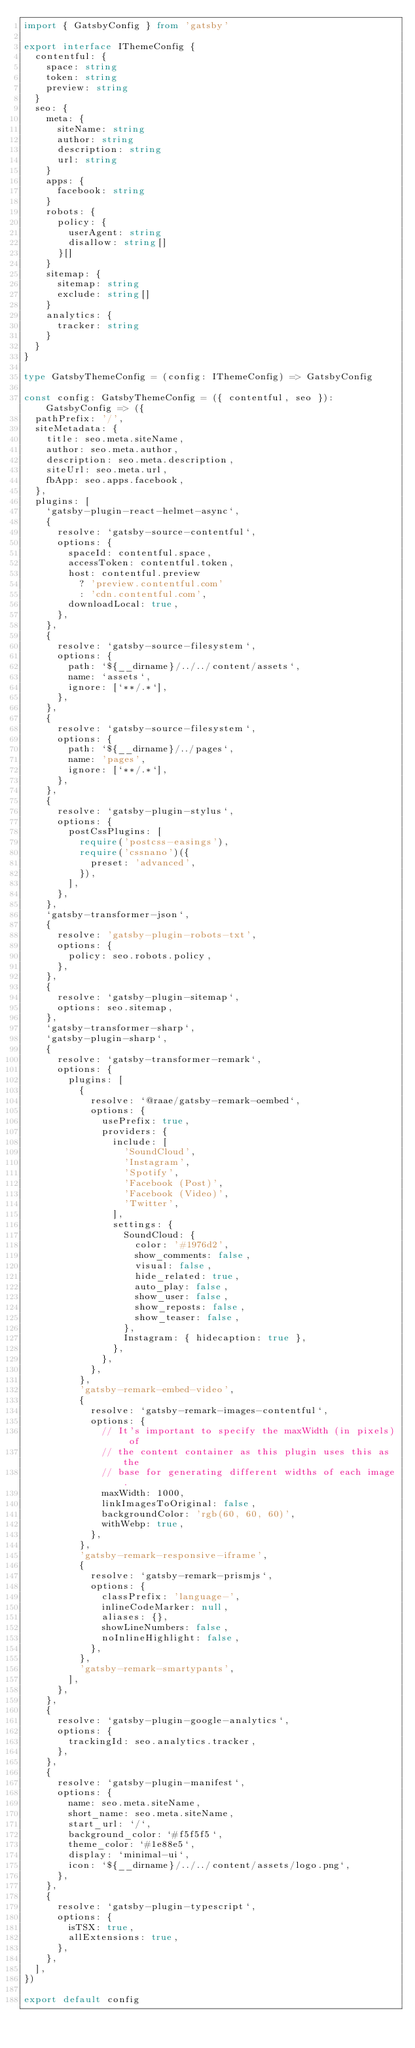Convert code to text. <code><loc_0><loc_0><loc_500><loc_500><_TypeScript_>import { GatsbyConfig } from 'gatsby'

export interface IThemeConfig {
  contentful: {
    space: string
    token: string
    preview: string
  }
  seo: {
    meta: {
      siteName: string
      author: string
      description: string
      url: string
    }
    apps: {
      facebook: string
    }
    robots: {
      policy: {
        userAgent: string
        disallow: string[]
      }[]
    }
    sitemap: {
      sitemap: string
      exclude: string[]
    }
    analytics: {
      tracker: string
    }
  }
}

type GatsbyThemeConfig = (config: IThemeConfig) => GatsbyConfig

const config: GatsbyThemeConfig = ({ contentful, seo }): GatsbyConfig => ({
  pathPrefix: '/',
  siteMetadata: {
    title: seo.meta.siteName,
    author: seo.meta.author,
    description: seo.meta.description,
    siteUrl: seo.meta.url,
    fbApp: seo.apps.facebook,
  },
  plugins: [
    `gatsby-plugin-react-helmet-async`,
    {
      resolve: `gatsby-source-contentful`,
      options: {
        spaceId: contentful.space,
        accessToken: contentful.token,
        host: contentful.preview
          ? 'preview.contentful.com'
          : 'cdn.contentful.com',
        downloadLocal: true,
      },
    },
    {
      resolve: `gatsby-source-filesystem`,
      options: {
        path: `${__dirname}/../../content/assets`,
        name: `assets`,
        ignore: [`**/.*`],
      },
    },
    {
      resolve: `gatsby-source-filesystem`,
      options: {
        path: `${__dirname}/../pages`,
        name: 'pages',
        ignore: [`**/.*`],
      },
    },
    {
      resolve: `gatsby-plugin-stylus`,
      options: {
        postCssPlugins: [
          require('postcss-easings'),
          require('cssnano')({
            preset: 'advanced',
          }),
        ],
      },
    },
    `gatsby-transformer-json`,
    {
      resolve: 'gatsby-plugin-robots-txt',
      options: {
        policy: seo.robots.policy,
      },
    },
    {
      resolve: `gatsby-plugin-sitemap`,
      options: seo.sitemap,
    },
    `gatsby-transformer-sharp`,
    `gatsby-plugin-sharp`,
    {
      resolve: `gatsby-transformer-remark`,
      options: {
        plugins: [
          {
            resolve: `@raae/gatsby-remark-oembed`,
            options: {
              usePrefix: true,
              providers: {
                include: [
                  'SoundCloud',
                  'Instagram',
                  'Spotify',
                  'Facebook (Post)',
                  'Facebook (Video)',
                  'Twitter',
                ],
                settings: {
                  SoundCloud: {
                    color: '#1976d2',
                    show_comments: false,
                    visual: false,
                    hide_related: true,
                    auto_play: false,
                    show_user: false,
                    show_reposts: false,
                    show_teaser: false,
                  },
                  Instagram: { hidecaption: true },
                },
              },
            },
          },
          'gatsby-remark-embed-video',
          {
            resolve: `gatsby-remark-images-contentful`,
            options: {
              // It's important to specify the maxWidth (in pixels) of
              // the content container as this plugin uses this as the
              // base for generating different widths of each image.
              maxWidth: 1000,
              linkImagesToOriginal: false,
              backgroundColor: 'rgb(60, 60, 60)',
              withWebp: true,
            },
          },
          'gatsby-remark-responsive-iframe',
          {
            resolve: `gatsby-remark-prismjs`,
            options: {
              classPrefix: 'language-',
              inlineCodeMarker: null,
              aliases: {},
              showLineNumbers: false,
              noInlineHighlight: false,
            },
          },
          'gatsby-remark-smartypants',
        ],
      },
    },
    {
      resolve: `gatsby-plugin-google-analytics`,
      options: {
        trackingId: seo.analytics.tracker,
      },
    },
    {
      resolve: `gatsby-plugin-manifest`,
      options: {
        name: seo.meta.siteName,
        short_name: seo.meta.siteName,
        start_url: `/`,
        background_color: `#f5f5f5`,
        theme_color: `#1e88e5`,
        display: `minimal-ui`,
        icon: `${__dirname}/../../content/assets/logo.png`,
      },
    },
    {
      resolve: `gatsby-plugin-typescript`,
      options: {
        isTSX: true,
        allExtensions: true,
      },
    },
  ],
})

export default config
</code> 